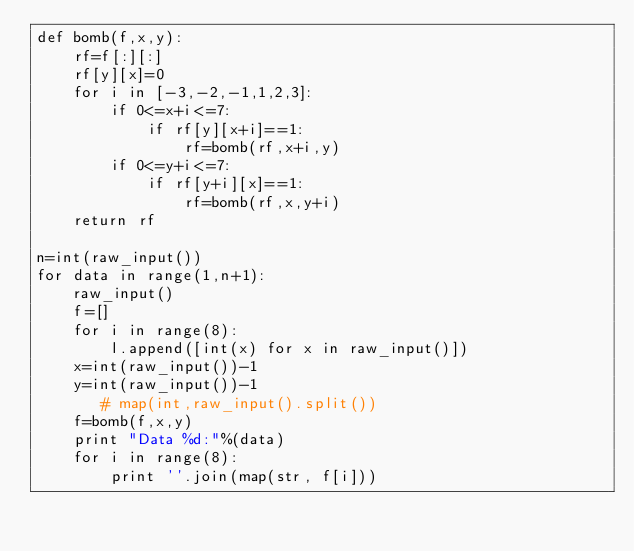Convert code to text. <code><loc_0><loc_0><loc_500><loc_500><_Python_>def bomb(f,x,y):
    rf=f[:][:]
    rf[y][x]=0
    for i in [-3,-2,-1,1,2,3]:
        if 0<=x+i<=7:
            if rf[y][x+i]==1:
                rf=bomb(rf,x+i,y)
        if 0<=y+i<=7:
            if rf[y+i][x]==1:
                rf=bomb(rf,x,y+i)
    return rf

n=int(raw_input())
for data in range(1,n+1):
    raw_input()
    f=[]
    for i in range(8):
        l.append([int(x) for x in raw_input()])
    x=int(raw_input())-1
    y=int(raw_input())-1
       # map(int,raw_input().split())
    f=bomb(f,x,y)
    print "Data %d:"%(data)
    for i in range(8):
        print ''.join(map(str, f[i]))</code> 